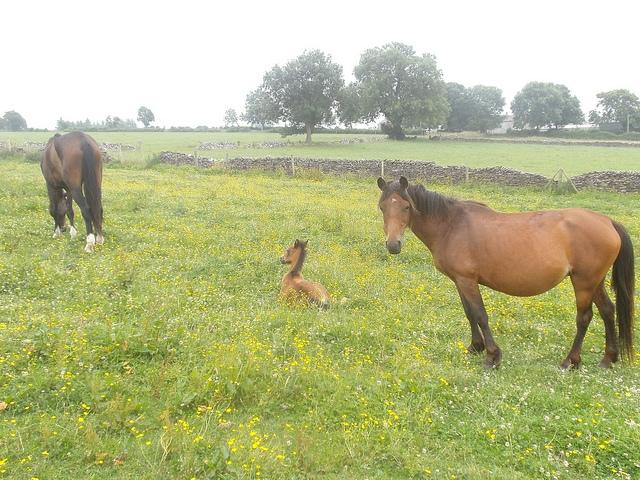Is there a fence?
Quick response, please. Yes. How many horses are there?
Answer briefly. 3. Does the baby horse run yet?
Be succinct. No. 